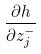<formula> <loc_0><loc_0><loc_500><loc_500>\frac { \partial h } { \partial z _ { j } ^ { - } }</formula> 